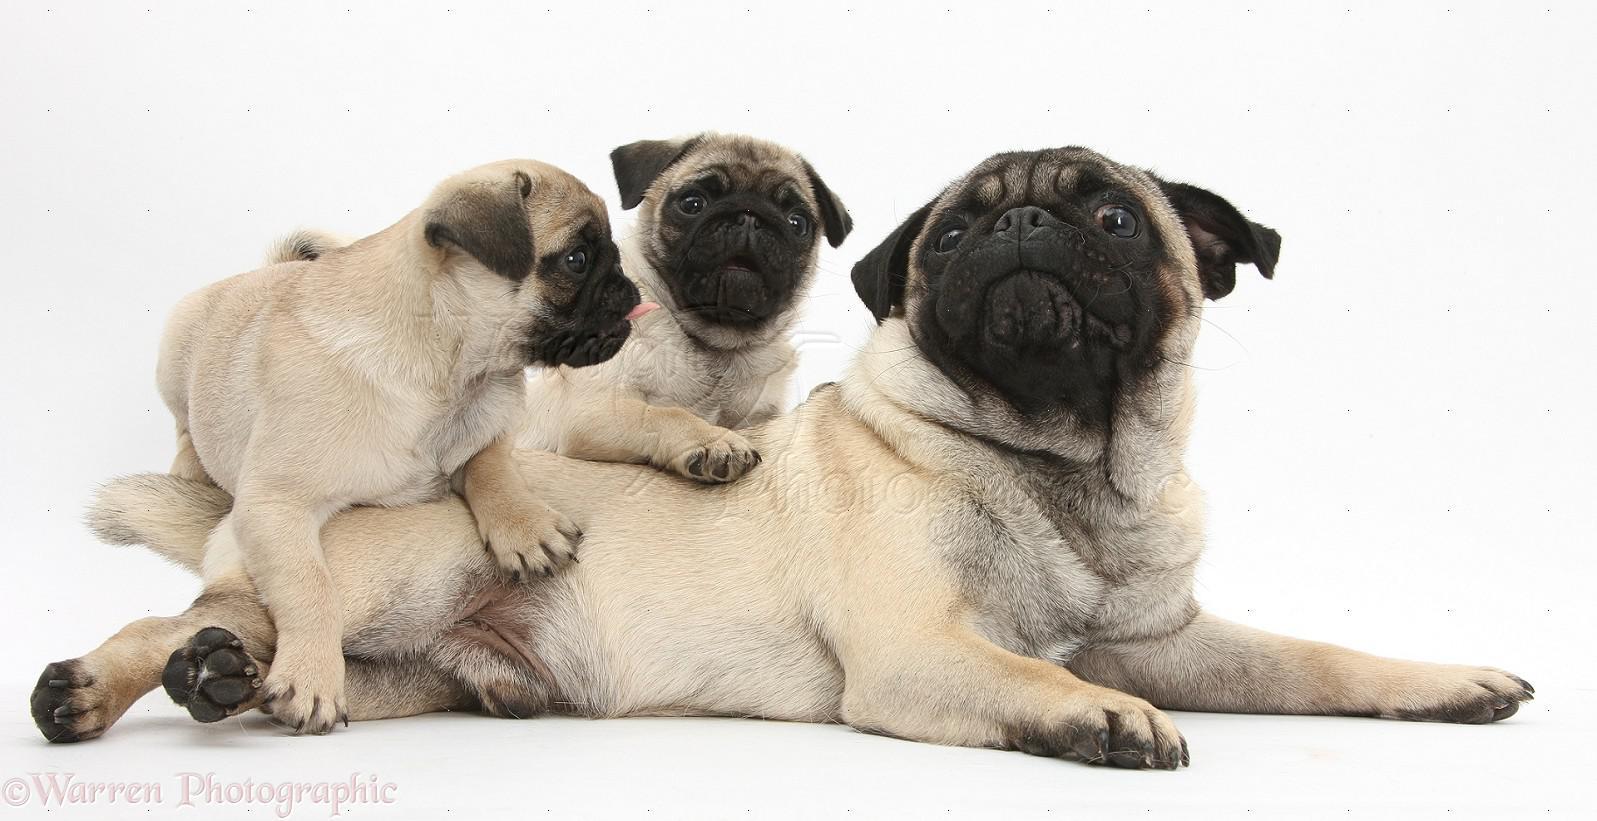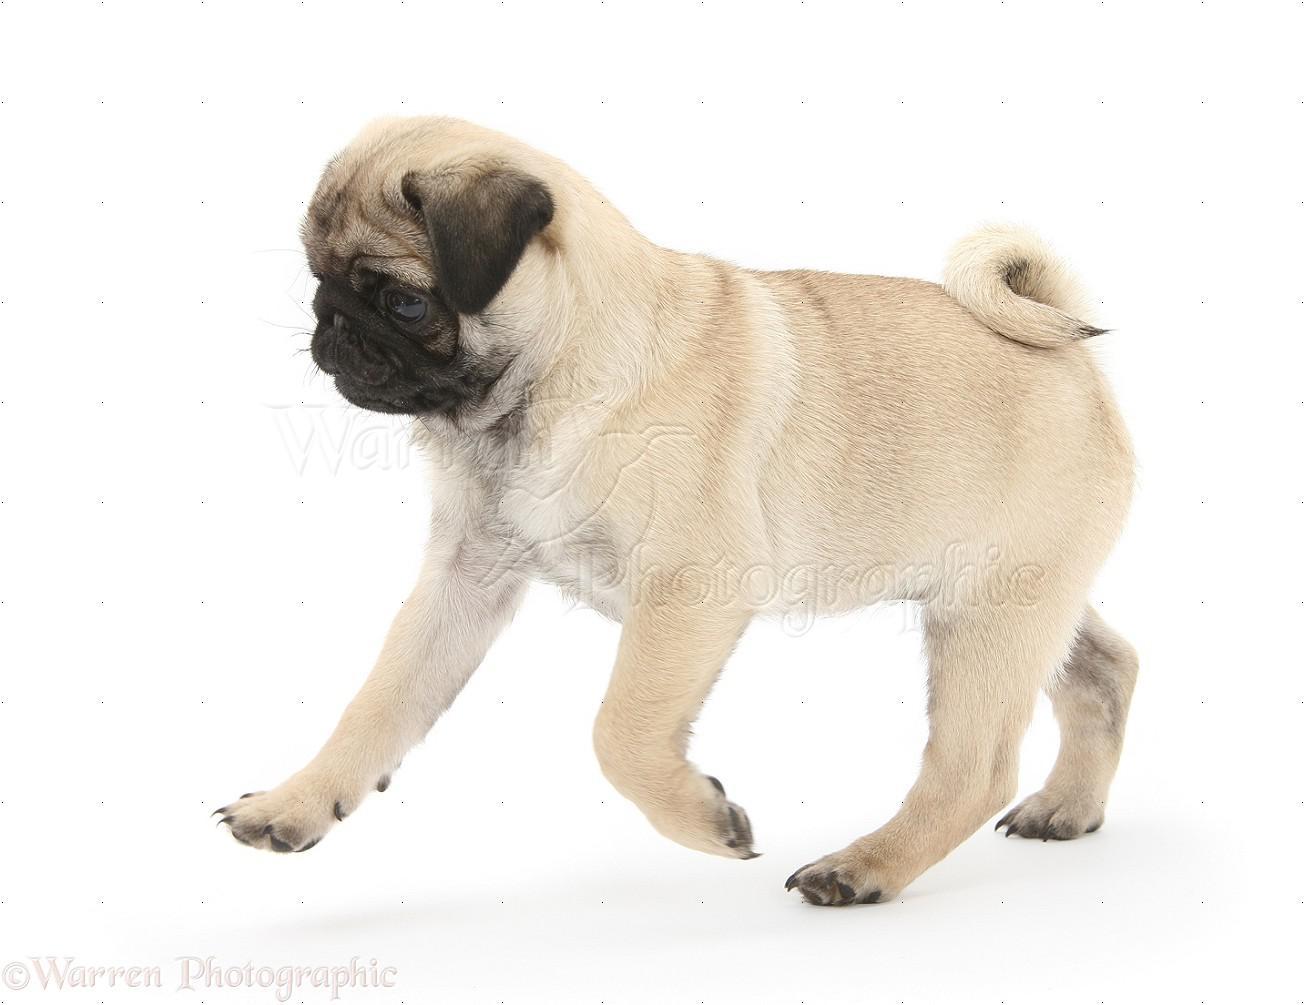The first image is the image on the left, the second image is the image on the right. Examine the images to the left and right. Is the description "There are atleast 4 pugs total." accurate? Answer yes or no. Yes. The first image is the image on the left, the second image is the image on the right. Given the left and right images, does the statement "A human hand can be seen touching one puppy." hold true? Answer yes or no. No. 